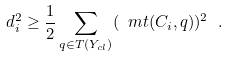Convert formula to latex. <formula><loc_0><loc_0><loc_500><loc_500>d _ { i } ^ { 2 } \geq \frac { 1 } { 2 } \sum _ { q \in T ( Y _ { c l } ) } ( \ m t ( C _ { i } , q ) ) ^ { 2 } \ .</formula> 